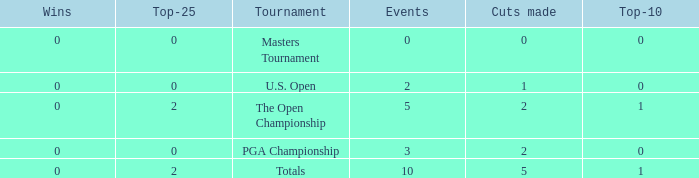What is the sum of top-10s for events with more than 0 wins? None. Can you give me this table as a dict? {'header': ['Wins', 'Top-25', 'Tournament', 'Events', 'Cuts made', 'Top-10'], 'rows': [['0', '0', 'Masters Tournament', '0', '0', '0'], ['0', '0', 'U.S. Open', '2', '1', '0'], ['0', '2', 'The Open Championship', '5', '2', '1'], ['0', '0', 'PGA Championship', '3', '2', '0'], ['0', '2', 'Totals', '10', '5', '1']]} 